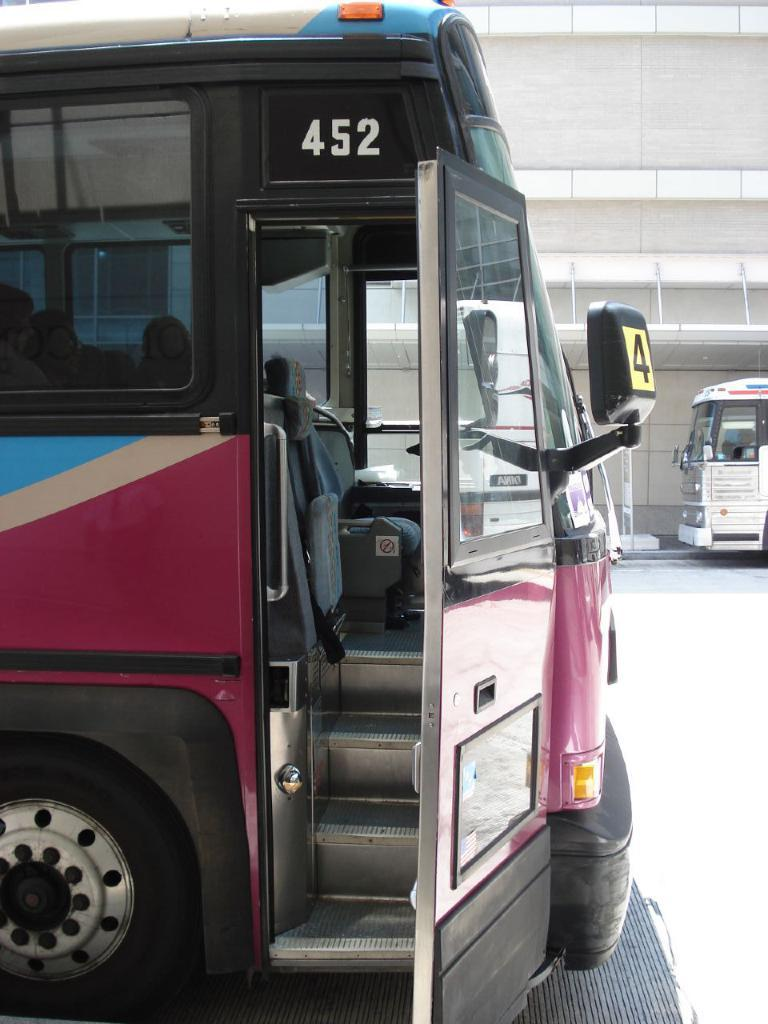<image>
Summarize the visual content of the image. The passenger door of bus 452 is open. 